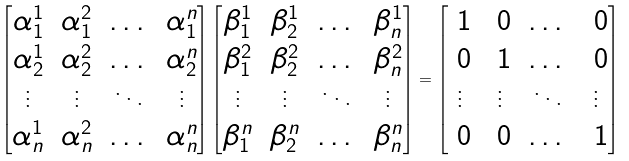Convert formula to latex. <formula><loc_0><loc_0><loc_500><loc_500>\begin{bmatrix} \alpha ^ { 1 } _ { 1 } & \alpha ^ { 2 } _ { 1 } & \dots & \alpha ^ { n } _ { 1 } \\ \alpha ^ { 1 } _ { 2 } & \alpha ^ { 2 } _ { 2 } & \dots & \alpha ^ { n } _ { 2 } \\ \vdots & \vdots & \ddots & \vdots \\ \alpha ^ { 1 } _ { n } & \alpha ^ { 2 } _ { n } & \dots & \alpha ^ { n } _ { n } \end{bmatrix} \begin{bmatrix} \beta ^ { 1 } _ { 1 } & \beta ^ { 1 } _ { 2 } & \dots & \beta ^ { 1 } _ { n } \\ \beta ^ { 2 } _ { 1 } & \beta ^ { 2 } _ { 2 } & \dots & \beta ^ { 2 } _ { n } \\ \vdots & \vdots & \ddots & \vdots \\ \beta ^ { n } _ { 1 } & \beta ^ { n } _ { 2 } & \dots & \beta ^ { n } _ { n } \end{bmatrix} = \begin{bmatrix} \ 1 & \ 0 & \dots & \ 0 \\ \ 0 & \ 1 & \dots & \ 0 \\ \vdots & \vdots & \ddots & \vdots \\ \ 0 & \ 0 & \dots & \ 1 \end{bmatrix}</formula> 